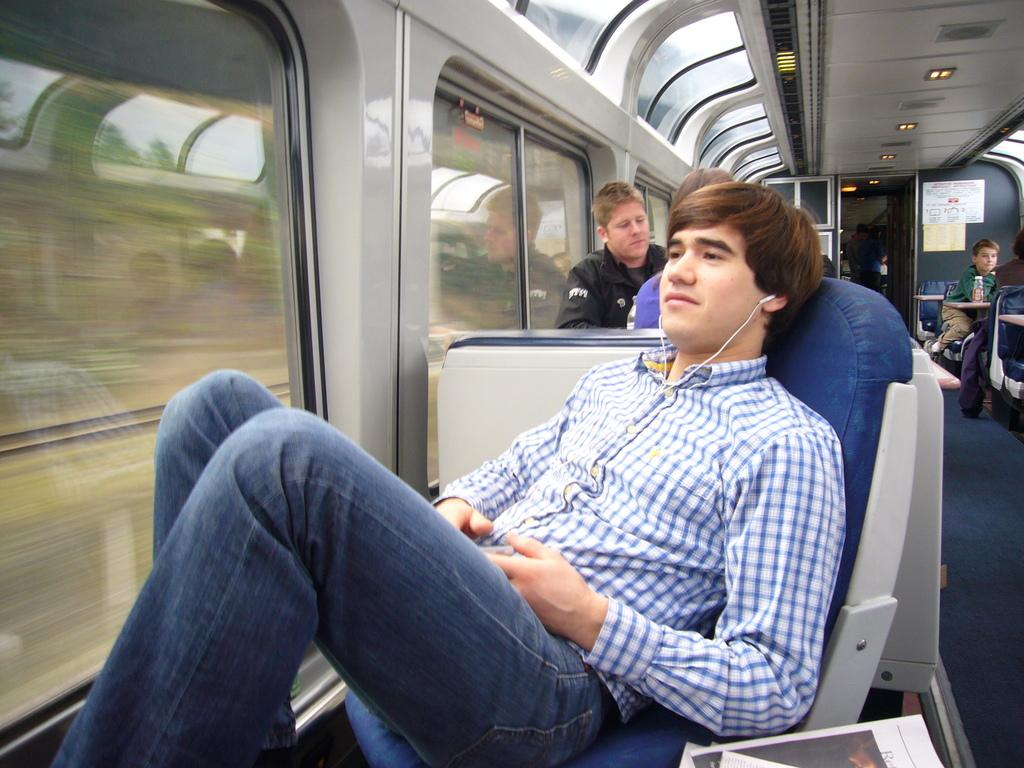What are the people in the image doing? The persons in the image are sitting on chairs. Where is the setting of the image? The setting appears to be inside a train. What is the person holding in the image? A person is holding an object in the image. What can be seen on the table or lap of one of the persons? A book is visible in the image. What is the purpose of the board in the image? The purpose of the board in the image is not clear, but it might be used for displaying information or announcements. What is the source of light in the image? There is a light in the image. Is it raining inside the train in the image? No, there is no indication of rain inside the train in the image. What is the relation between the persons sitting on chairs in the image? The relation between the persons sitting on chairs in the image is not mentioned or visible, so it cannot be determined. 